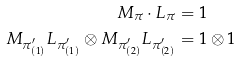<formula> <loc_0><loc_0><loc_500><loc_500>M _ { \pi } \cdot L _ { \pi } & = 1 \\ M _ { \pi ^ { \prime } _ { ( 1 ) } } L _ { \pi ^ { \prime } _ { ( 1 ) } } \otimes M _ { \pi ^ { \prime } _ { ( 2 ) } } L _ { \pi ^ { \prime } _ { ( 2 ) } } & = 1 \otimes 1</formula> 